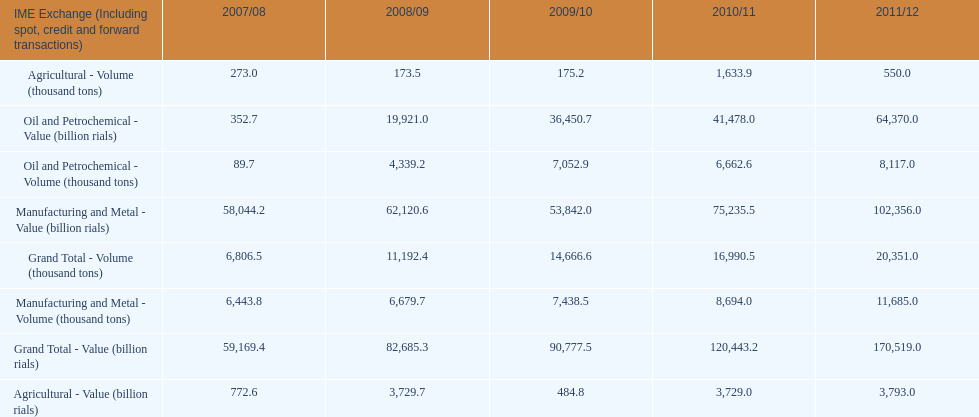Parse the table in full. {'header': ['IME Exchange (Including spot, credit and forward transactions)', '2007/08', '2008/09', '2009/10', '2010/11', '2011/12'], 'rows': [['Agricultural - Volume (thousand tons)', '273.0', '173.5', '175.2', '1,633.9', '550.0'], ['Oil and Petrochemical - Value (billion rials)', '352.7', '19,921.0', '36,450.7', '41,478.0', '64,370.0'], ['Oil and Petrochemical - Volume (thousand tons)', '89.7', '4,339.2', '7,052.9', '6,662.6', '8,117.0'], ['Manufacturing and Metal - Value (billion rials)', '58,044.2', '62,120.6', '53,842.0', '75,235.5', '102,356.0'], ['Grand Total - Volume (thousand tons)', '6,806.5', '11,192.4', '14,666.6', '16,990.5', '20,351.0'], ['Manufacturing and Metal - Volume (thousand tons)', '6,443.8', '6,679.7', '7,438.5', '8,694.0', '11,685.0'], ['Grand Total - Value (billion rials)', '59,169.4', '82,685.3', '90,777.5', '120,443.2', '170,519.0'], ['Agricultural - Value (billion rials)', '772.6', '3,729.7', '484.8', '3,729.0', '3,793.0']]} Did 2010/11 or 2011/12 make more in grand total value? 2011/12. 